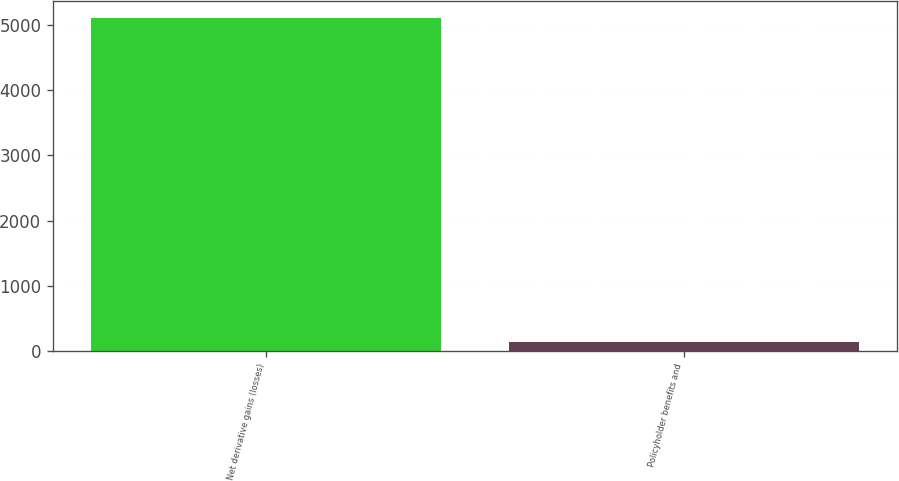Convert chart. <chart><loc_0><loc_0><loc_500><loc_500><bar_chart><fcel>Net derivative gains (losses)<fcel>Policyholder benefits and<nl><fcel>5104<fcel>139<nl></chart> 